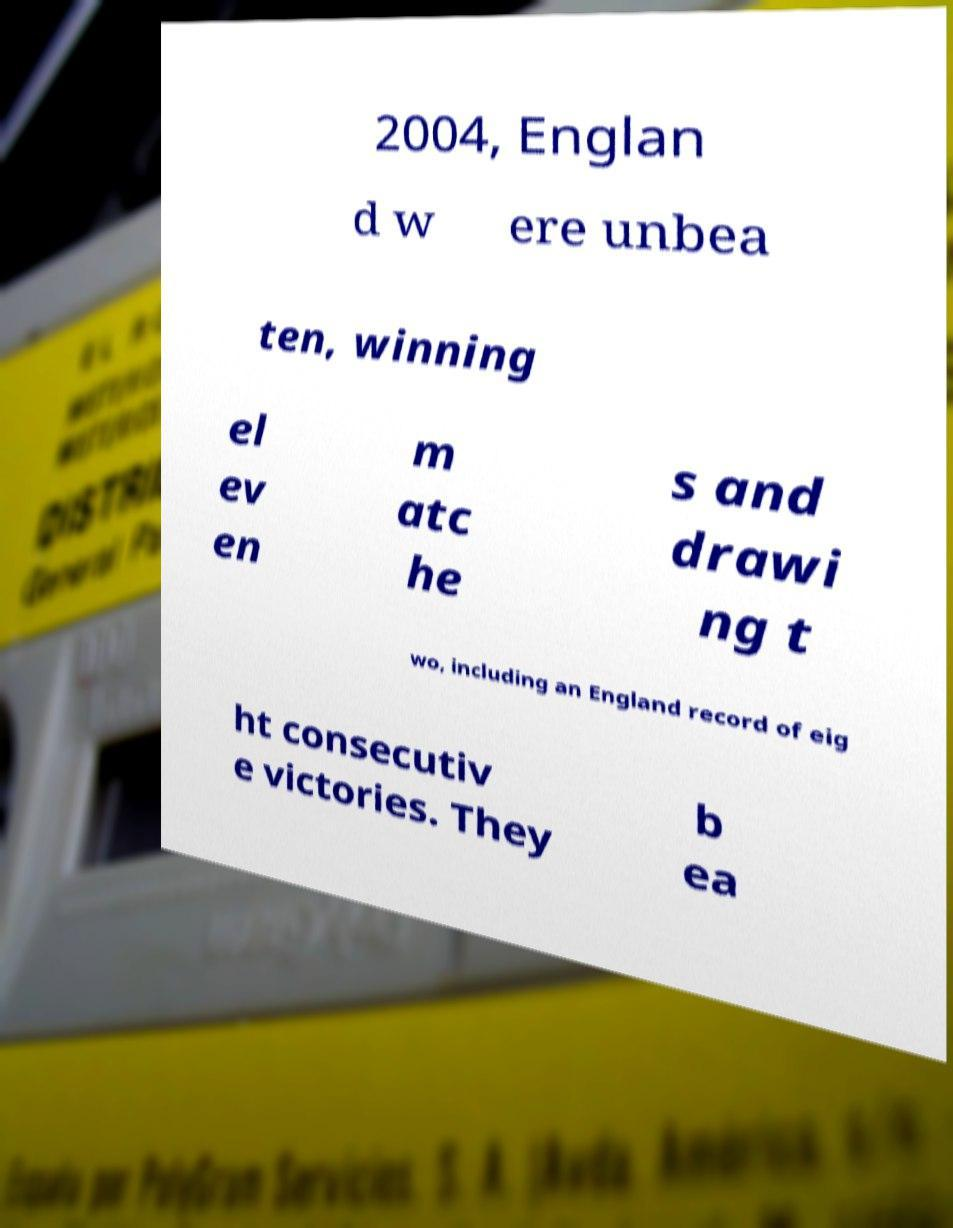Can you accurately transcribe the text from the provided image for me? 2004, Englan d w ere unbea ten, winning el ev en m atc he s and drawi ng t wo, including an England record of eig ht consecutiv e victories. They b ea 